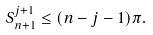<formula> <loc_0><loc_0><loc_500><loc_500>S _ { n + 1 } ^ { j + 1 } \leq ( n - j - 1 ) \pi .</formula> 